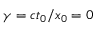Convert formula to latex. <formula><loc_0><loc_0><loc_500><loc_500>\gamma = c t _ { 0 } / x _ { 0 } = 0</formula> 